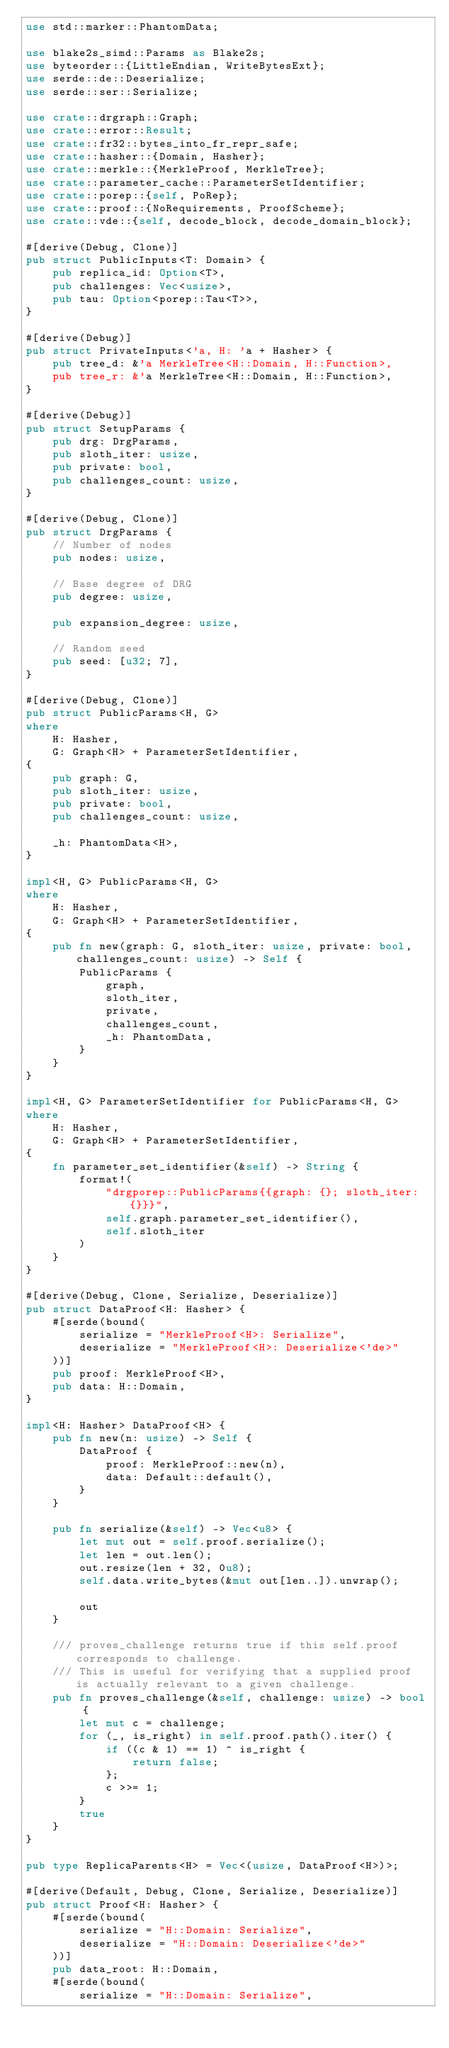<code> <loc_0><loc_0><loc_500><loc_500><_Rust_>use std::marker::PhantomData;

use blake2s_simd::Params as Blake2s;
use byteorder::{LittleEndian, WriteBytesExt};
use serde::de::Deserialize;
use serde::ser::Serialize;

use crate::drgraph::Graph;
use crate::error::Result;
use crate::fr32::bytes_into_fr_repr_safe;
use crate::hasher::{Domain, Hasher};
use crate::merkle::{MerkleProof, MerkleTree};
use crate::parameter_cache::ParameterSetIdentifier;
use crate::porep::{self, PoRep};
use crate::proof::{NoRequirements, ProofScheme};
use crate::vde::{self, decode_block, decode_domain_block};

#[derive(Debug, Clone)]
pub struct PublicInputs<T: Domain> {
    pub replica_id: Option<T>,
    pub challenges: Vec<usize>,
    pub tau: Option<porep::Tau<T>>,
}

#[derive(Debug)]
pub struct PrivateInputs<'a, H: 'a + Hasher> {
    pub tree_d: &'a MerkleTree<H::Domain, H::Function>,
    pub tree_r: &'a MerkleTree<H::Domain, H::Function>,
}

#[derive(Debug)]
pub struct SetupParams {
    pub drg: DrgParams,
    pub sloth_iter: usize,
    pub private: bool,
    pub challenges_count: usize,
}

#[derive(Debug, Clone)]
pub struct DrgParams {
    // Number of nodes
    pub nodes: usize,

    // Base degree of DRG
    pub degree: usize,

    pub expansion_degree: usize,

    // Random seed
    pub seed: [u32; 7],
}

#[derive(Debug, Clone)]
pub struct PublicParams<H, G>
where
    H: Hasher,
    G: Graph<H> + ParameterSetIdentifier,
{
    pub graph: G,
    pub sloth_iter: usize,
    pub private: bool,
    pub challenges_count: usize,

    _h: PhantomData<H>,
}

impl<H, G> PublicParams<H, G>
where
    H: Hasher,
    G: Graph<H> + ParameterSetIdentifier,
{
    pub fn new(graph: G, sloth_iter: usize, private: bool, challenges_count: usize) -> Self {
        PublicParams {
            graph,
            sloth_iter,
            private,
            challenges_count,
            _h: PhantomData,
        }
    }
}

impl<H, G> ParameterSetIdentifier for PublicParams<H, G>
where
    H: Hasher,
    G: Graph<H> + ParameterSetIdentifier,
{
    fn parameter_set_identifier(&self) -> String {
        format!(
            "drgporep::PublicParams{{graph: {}; sloth_iter: {}}}",
            self.graph.parameter_set_identifier(),
            self.sloth_iter
        )
    }
}

#[derive(Debug, Clone, Serialize, Deserialize)]
pub struct DataProof<H: Hasher> {
    #[serde(bound(
        serialize = "MerkleProof<H>: Serialize",
        deserialize = "MerkleProof<H>: Deserialize<'de>"
    ))]
    pub proof: MerkleProof<H>,
    pub data: H::Domain,
}

impl<H: Hasher> DataProof<H> {
    pub fn new(n: usize) -> Self {
        DataProof {
            proof: MerkleProof::new(n),
            data: Default::default(),
        }
    }

    pub fn serialize(&self) -> Vec<u8> {
        let mut out = self.proof.serialize();
        let len = out.len();
        out.resize(len + 32, 0u8);
        self.data.write_bytes(&mut out[len..]).unwrap();

        out
    }

    /// proves_challenge returns true if this self.proof corresponds to challenge.
    /// This is useful for verifying that a supplied proof is actually relevant to a given challenge.
    pub fn proves_challenge(&self, challenge: usize) -> bool {
        let mut c = challenge;
        for (_, is_right) in self.proof.path().iter() {
            if ((c & 1) == 1) ^ is_right {
                return false;
            };
            c >>= 1;
        }
        true
    }
}

pub type ReplicaParents<H> = Vec<(usize, DataProof<H>)>;

#[derive(Default, Debug, Clone, Serialize, Deserialize)]
pub struct Proof<H: Hasher> {
    #[serde(bound(
        serialize = "H::Domain: Serialize",
        deserialize = "H::Domain: Deserialize<'de>"
    ))]
    pub data_root: H::Domain,
    #[serde(bound(
        serialize = "H::Domain: Serialize",</code> 